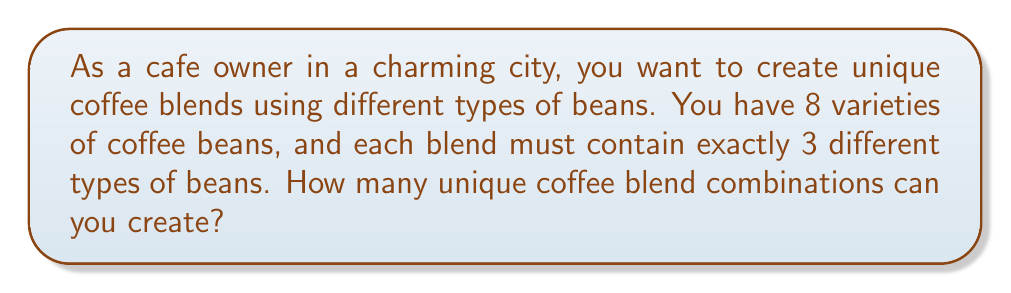Solve this math problem. To solve this problem, we need to use the combination formula. We are selecting 3 beans out of 8 without repetition, and the order doesn't matter (as it's a blend).

The formula for combinations is:

$$C(n,r) = \frac{n!}{r!(n-r)!}$$

Where:
$n$ is the total number of items to choose from (in this case, 8 bean varieties)
$r$ is the number of items being chosen (in this case, 3 beans for each blend)

Let's substitute our values:

$$C(8,3) = \frac{8!}{3!(8-3)!} = \frac{8!}{3!5!}$$

Now, let's calculate:

$$\frac{8!}{3!5!} = \frac{8 \times 7 \times 6 \times 5!}{(3 \times 2 \times 1) \times 5!}$$

The $5!$ cancels out in the numerator and denominator:

$$= \frac{8 \times 7 \times 6}{3 \times 2 \times 1} = \frac{336}{6} = 56$$

Therefore, you can create 56 unique coffee blend combinations using 3 different types of beans from your 8 varieties.
Answer: 56 unique coffee blend combinations 